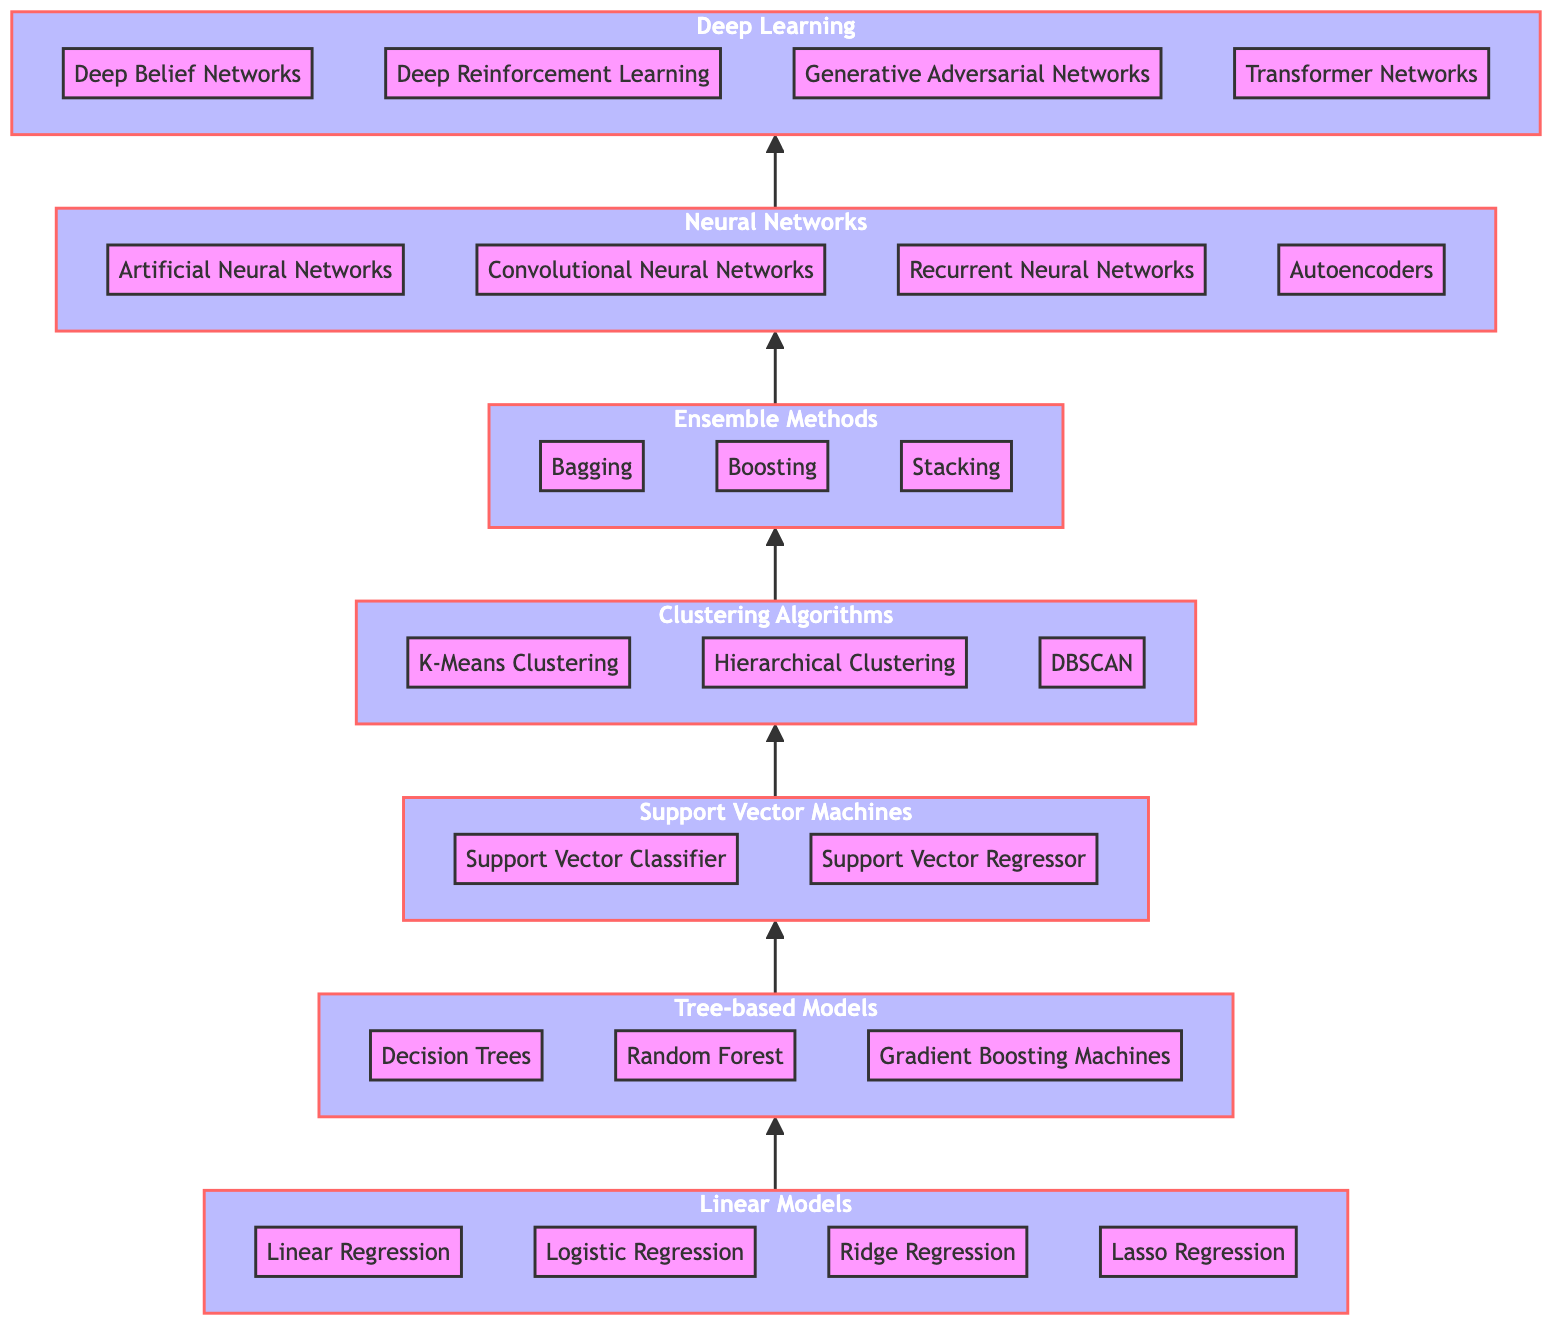What is the topmost level in the diagram? The diagram is structured in a bottom-to-top manner, meaning the topmost level represents the most advanced machine learning algorithms. According to the hierarchy, the last level is "Deep Learning," which is positioned at the highest point.
Answer: Deep Learning How many algorithms are listed under Tree-based Models? By examining the algorithms listed under the "Tree-based Models" node, we can see three specific algorithms: "Decision Trees," "Random Forest," and "Gradient Boosting Machines." Counting these, we find that there are three algorithms.
Answer: 3 What comes directly after Neural Networks in the hierarchy? To identify what follows "Neural Networks" in the diagram, we look at the direction of the flow from the level of "Neural Networks." The arrow points upward towards the next node, which is "Deep Learning."
Answer: Deep Learning Which level includes K-Means Clustering? The diagram categorizes "K-Means Clustering" under the "Clustering Algorithms" subgraph. This places it at Level 4, as it is the first algorithm listed in that category of models in the hierarchy.
Answer: Level 4 How many total levels are present in this diagram? By reviewing the structure of the diagram, we can count the main levels presented, which are seven in total: Linear Models, Tree-based Models, Support Vector Machines, Clustering Algorithms, Ensemble Methods, Neural Networks, and Deep Learning.
Answer: 7 What type of models does the Level 5 represent? The models classified at Level 5 of the diagram consist of "Ensemble Methods." This term refers to strategies that combine multiple learning algorithms to produce better predictive performance.
Answer: Ensemble Methods Which algorithm is situated between Random Forest and Autoencoders? To determine the algorithm between "Random Forest" and "Autoencoders," we track the upward flow from "Random Forest" at Level 2, connect this to Level 5 for "Ensemble Methods," then go up to Level 6, where "Autoencoders" is located. The algorithm situated directly between them is "Gradient Boosting Machines," which falls under Level 2.
Answer: Gradient Boosting Machines 